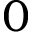Convert formula to latex. <formula><loc_0><loc_0><loc_500><loc_500>0</formula> 